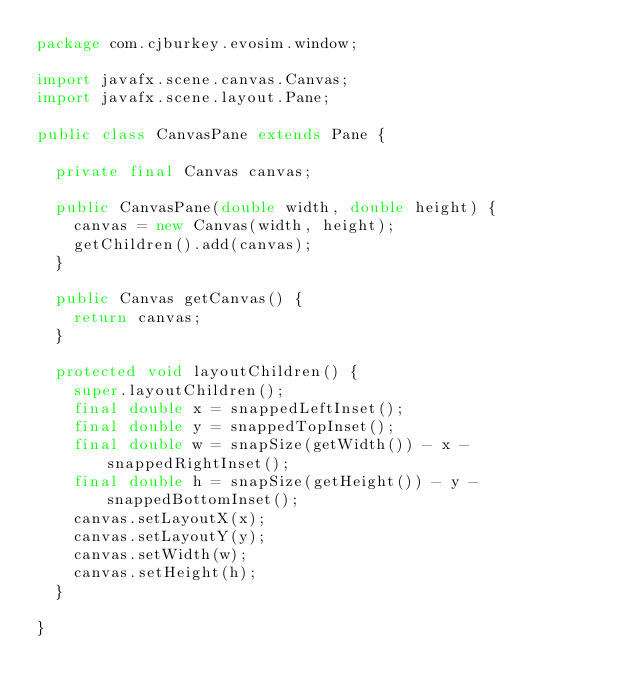Convert code to text. <code><loc_0><loc_0><loc_500><loc_500><_Java_>package com.cjburkey.evosim.window;

import javafx.scene.canvas.Canvas;
import javafx.scene.layout.Pane;

public class CanvasPane extends Pane {
	
	private final Canvas canvas;
	
	public CanvasPane(double width, double height) {
		canvas = new Canvas(width, height);
		getChildren().add(canvas);
	}
	
	public Canvas getCanvas() {
		return canvas;
	}
	
	protected void layoutChildren() {
		super.layoutChildren();
		final double x = snappedLeftInset();
		final double y = snappedTopInset();
		final double w = snapSize(getWidth()) - x - snappedRightInset();
		final double h = snapSize(getHeight()) - y - snappedBottomInset();
		canvas.setLayoutX(x);
		canvas.setLayoutY(y);
		canvas.setWidth(w);
		canvas.setHeight(h);
	}
	
}</code> 